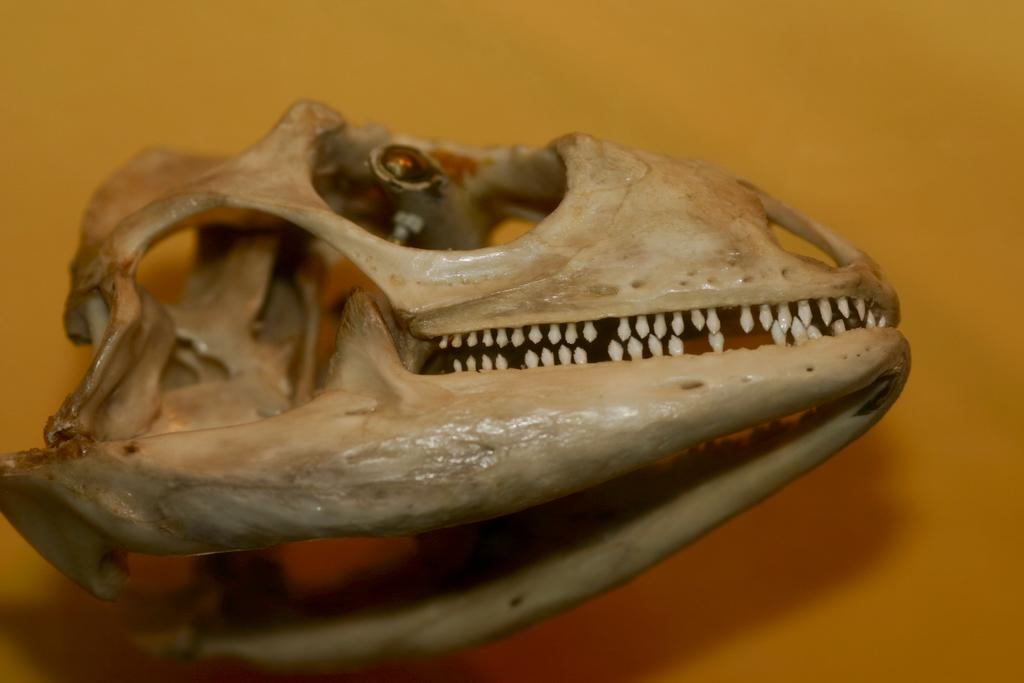What is the main subject of the image? The main subject of the image is a skull of an animal. What type of wine is being served with the linen tablecloth in the image? There is no wine or linen tablecloth present in the image; it only features a skull of an animal. 